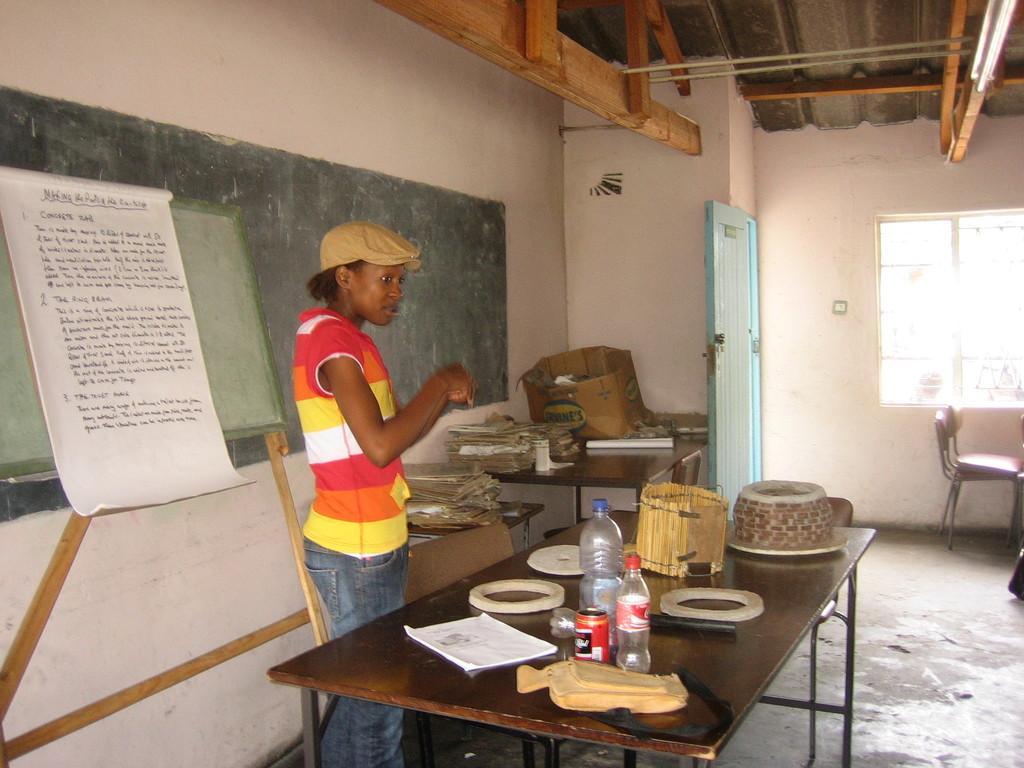Describe this image in one or two sentences. there is a table. on the table there is a book, bottles. at the left there is a person standing. behind him there is a board. at the right there is a window and a chair. 